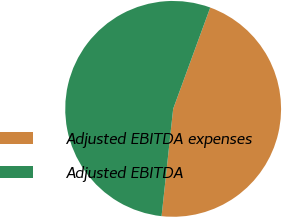<chart> <loc_0><loc_0><loc_500><loc_500><pie_chart><fcel>Adjusted EBITDA expenses<fcel>Adjusted EBITDA<nl><fcel>46.13%<fcel>53.87%<nl></chart> 